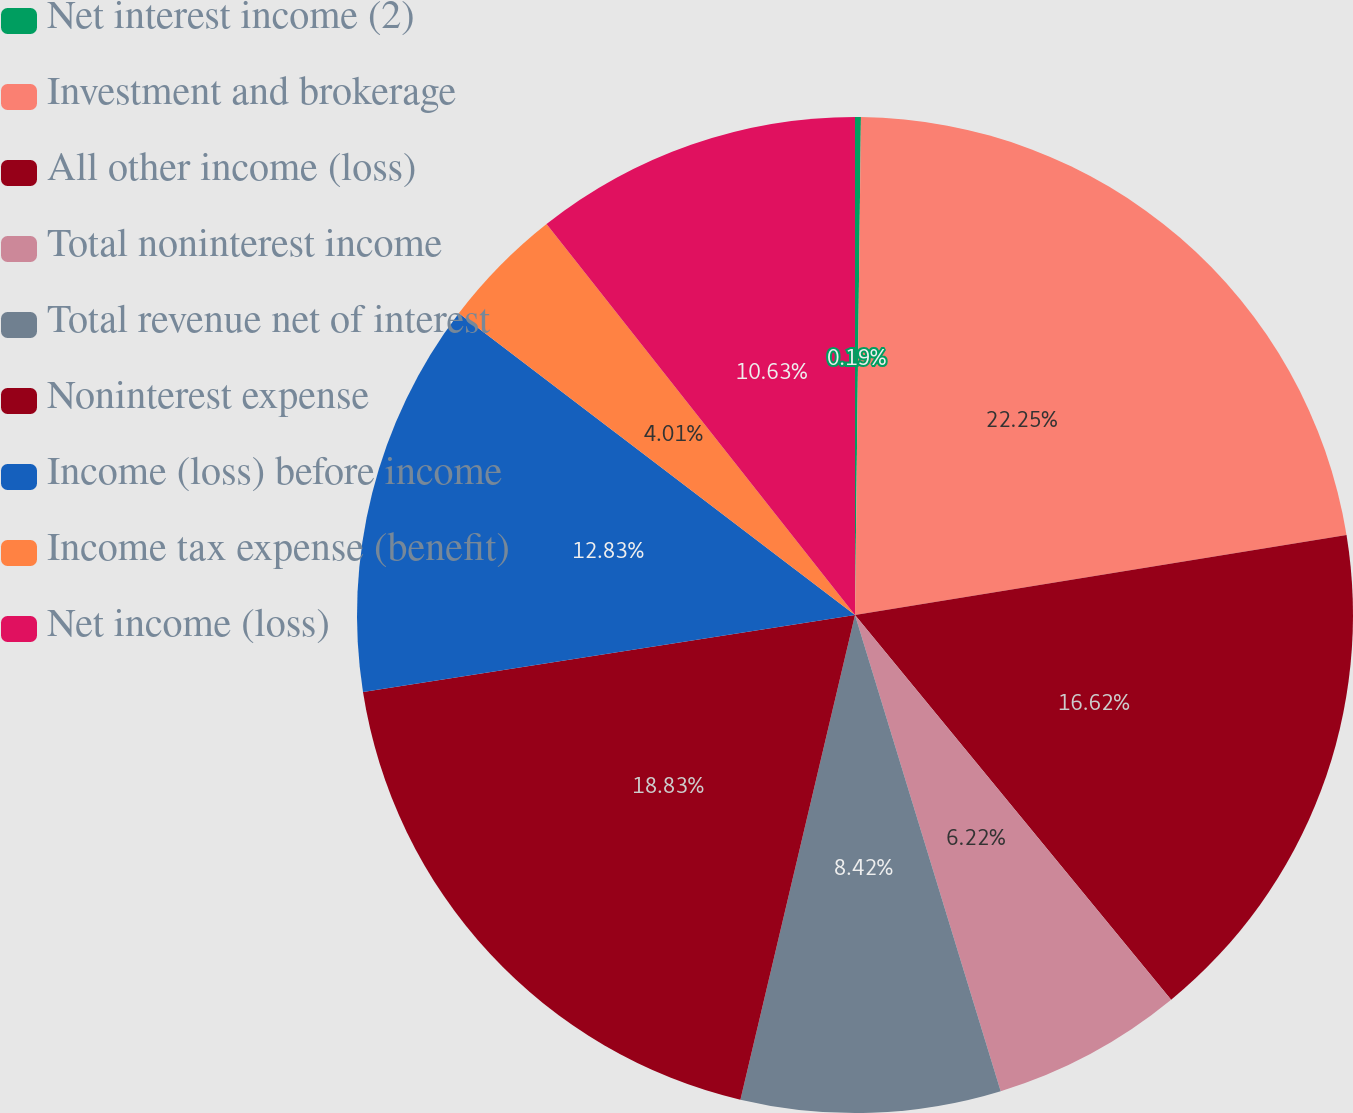Convert chart. <chart><loc_0><loc_0><loc_500><loc_500><pie_chart><fcel>Net interest income (2)<fcel>Investment and brokerage<fcel>All other income (loss)<fcel>Total noninterest income<fcel>Total revenue net of interest<fcel>Noninterest expense<fcel>Income (loss) before income<fcel>Income tax expense (benefit)<fcel>Net income (loss)<nl><fcel>0.19%<fcel>22.24%<fcel>16.62%<fcel>6.22%<fcel>8.42%<fcel>18.83%<fcel>12.83%<fcel>4.01%<fcel>10.63%<nl></chart> 